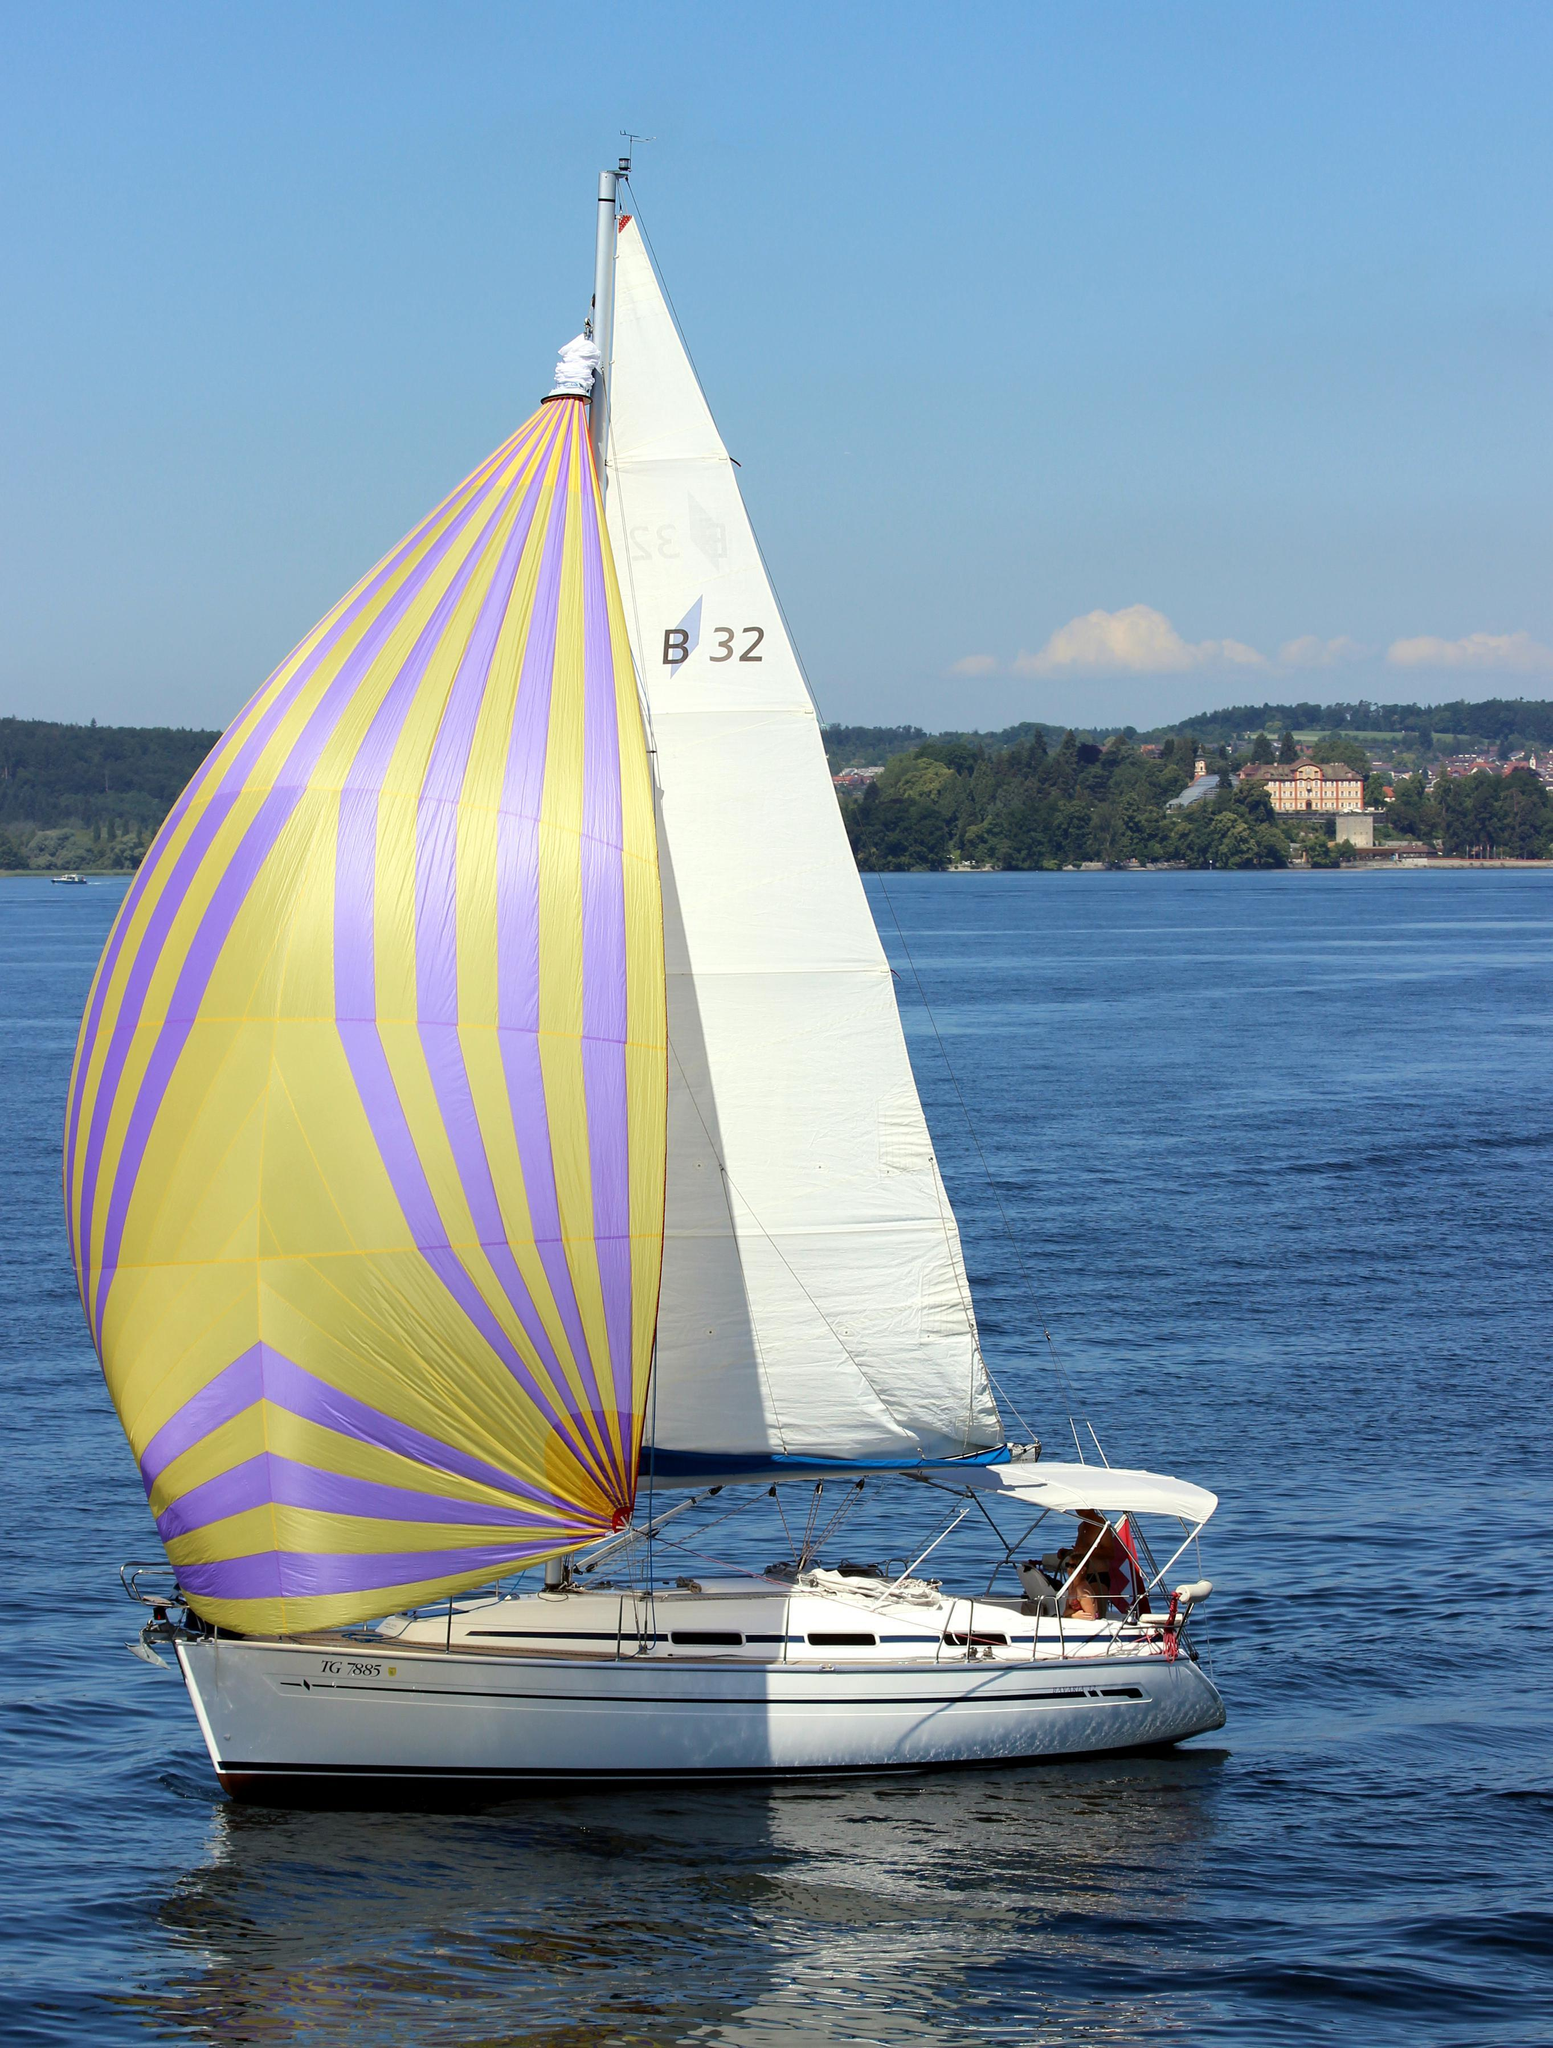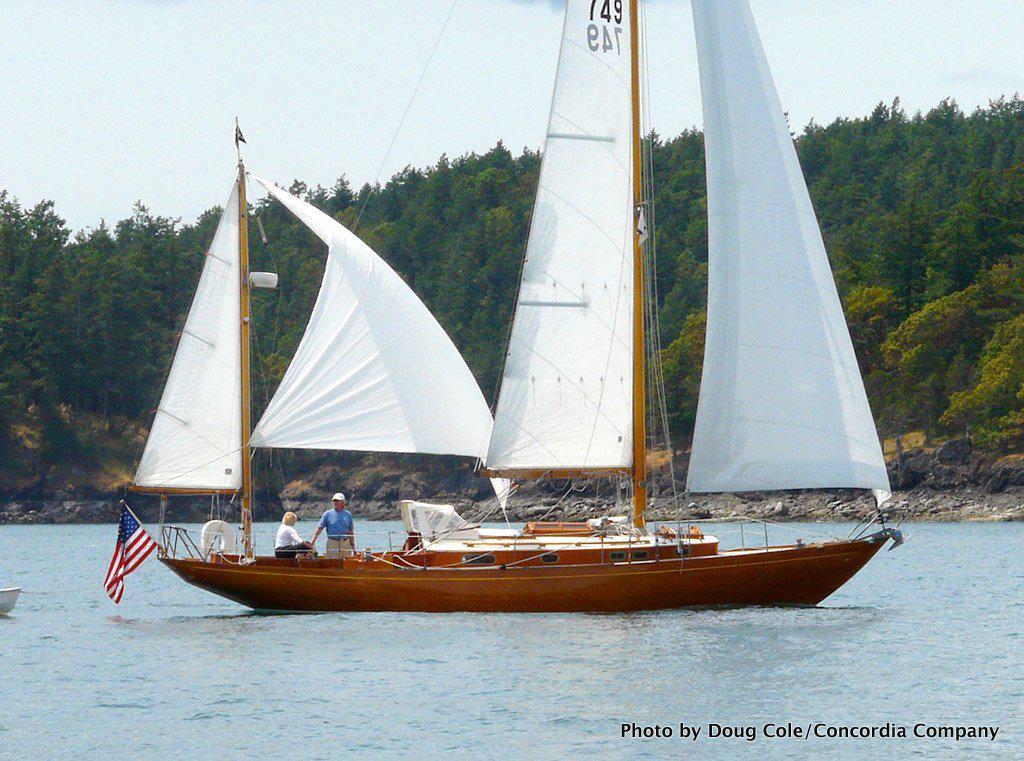The first image is the image on the left, the second image is the image on the right. For the images shown, is this caption "A sailboat with red sails is in the water." true? Answer yes or no. No. 